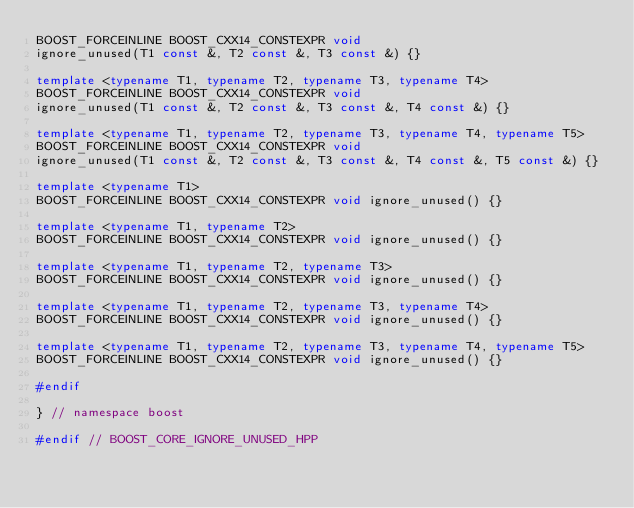<code> <loc_0><loc_0><loc_500><loc_500><_C++_>BOOST_FORCEINLINE BOOST_CXX14_CONSTEXPR void
ignore_unused(T1 const &, T2 const &, T3 const &) {}

template <typename T1, typename T2, typename T3, typename T4>
BOOST_FORCEINLINE BOOST_CXX14_CONSTEXPR void
ignore_unused(T1 const &, T2 const &, T3 const &, T4 const &) {}

template <typename T1, typename T2, typename T3, typename T4, typename T5>
BOOST_FORCEINLINE BOOST_CXX14_CONSTEXPR void
ignore_unused(T1 const &, T2 const &, T3 const &, T4 const &, T5 const &) {}

template <typename T1>
BOOST_FORCEINLINE BOOST_CXX14_CONSTEXPR void ignore_unused() {}

template <typename T1, typename T2>
BOOST_FORCEINLINE BOOST_CXX14_CONSTEXPR void ignore_unused() {}

template <typename T1, typename T2, typename T3>
BOOST_FORCEINLINE BOOST_CXX14_CONSTEXPR void ignore_unused() {}

template <typename T1, typename T2, typename T3, typename T4>
BOOST_FORCEINLINE BOOST_CXX14_CONSTEXPR void ignore_unused() {}

template <typename T1, typename T2, typename T3, typename T4, typename T5>
BOOST_FORCEINLINE BOOST_CXX14_CONSTEXPR void ignore_unused() {}

#endif

} // namespace boost

#endif // BOOST_CORE_IGNORE_UNUSED_HPP
</code> 